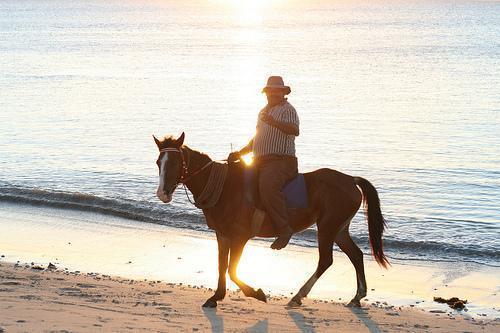How many people are shown?
Give a very brief answer. 1. How many hands are on the reigns?
Give a very brief answer. 1. 